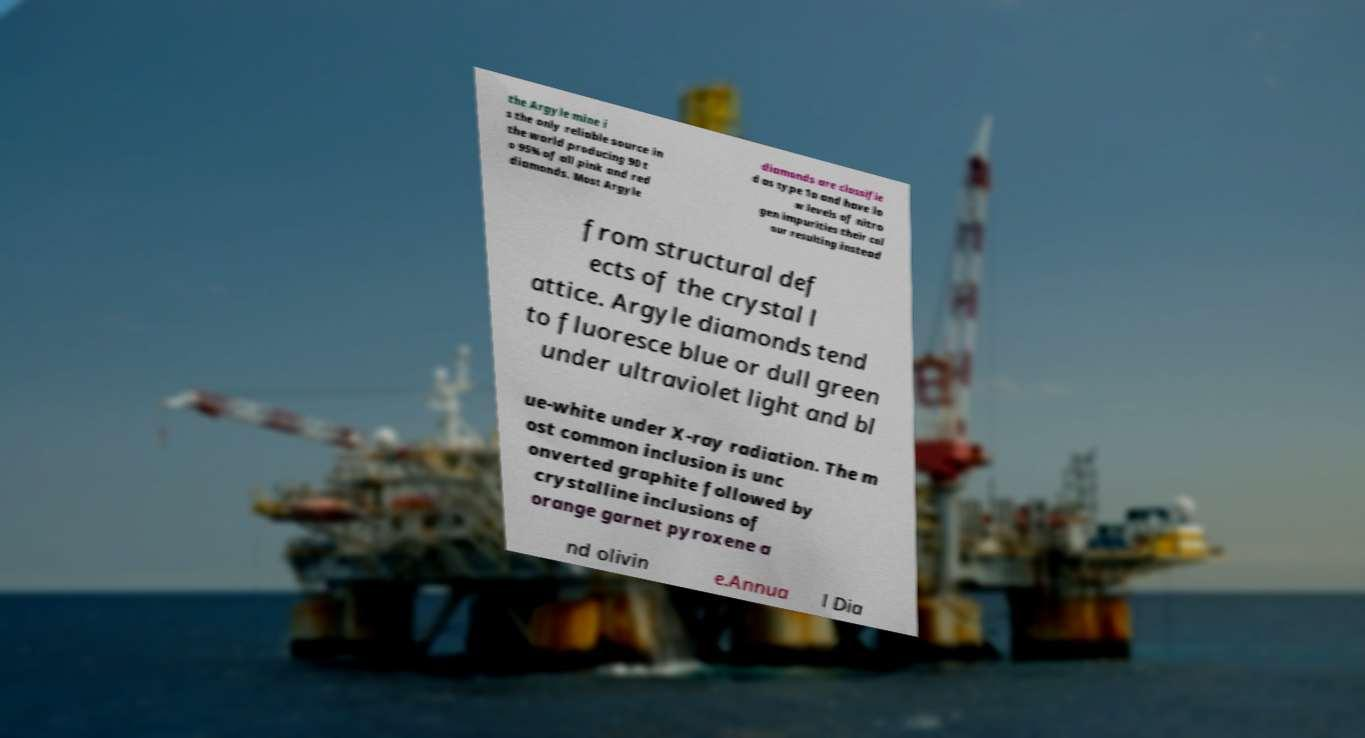There's text embedded in this image that I need extracted. Can you transcribe it verbatim? the Argyle mine i s the only reliable source in the world producing 90 t o 95% of all pink and red diamonds. Most Argyle diamonds are classifie d as type 1a and have lo w levels of nitro gen impurities their col our resulting instead from structural def ects of the crystal l attice. Argyle diamonds tend to fluoresce blue or dull green under ultraviolet light and bl ue-white under X-ray radiation. The m ost common inclusion is unc onverted graphite followed by crystalline inclusions of orange garnet pyroxene a nd olivin e.Annua l Dia 